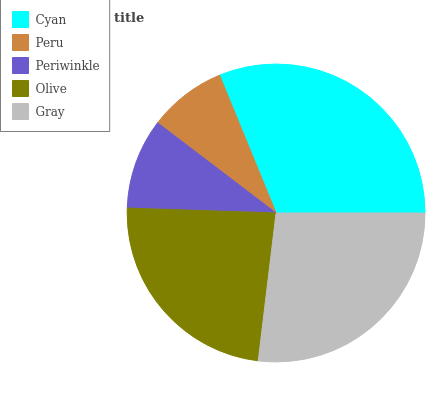Is Peru the minimum?
Answer yes or no. Yes. Is Cyan the maximum?
Answer yes or no. Yes. Is Periwinkle the minimum?
Answer yes or no. No. Is Periwinkle the maximum?
Answer yes or no. No. Is Periwinkle greater than Peru?
Answer yes or no. Yes. Is Peru less than Periwinkle?
Answer yes or no. Yes. Is Peru greater than Periwinkle?
Answer yes or no. No. Is Periwinkle less than Peru?
Answer yes or no. No. Is Olive the high median?
Answer yes or no. Yes. Is Olive the low median?
Answer yes or no. Yes. Is Peru the high median?
Answer yes or no. No. Is Gray the low median?
Answer yes or no. No. 